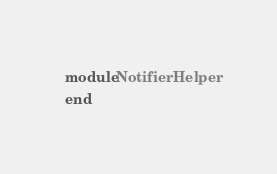<code> <loc_0><loc_0><loc_500><loc_500><_Ruby_>module NotifierHelper
end
</code> 